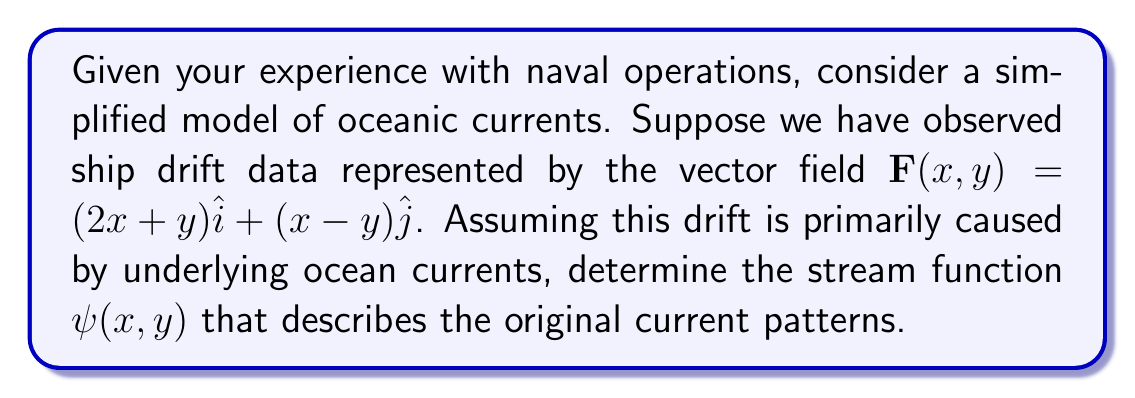Solve this math problem. To solve this inverse problem and determine the original oceanic current patterns from the observed ship drift data, we'll follow these steps:

1) Recall that for a two-dimensional incompressible flow, the velocity field $\mathbf{v}$ can be expressed in terms of a stream function $\psi$ as:

   $\mathbf{v} = \nabla \times (\psi \hat{k}) = \left(\frac{\partial \psi}{\partial y}\right)\hat{i} - \left(\frac{\partial \psi}{\partial x}\right)\hat{j}$

2) In our case, we're given the drift vector field $\mathbf{F}$, which we assume represents the velocity field of the ocean currents:

   $\mathbf{F}(x,y) = (2x+y)\hat{i} + (x-y)\hat{j}$

3) Comparing this with the expression for $\mathbf{v}$ in terms of $\psi$, we can write:

   $\frac{\partial \psi}{\partial y} = 2x+y$
   $-\frac{\partial \psi}{\partial x} = x-y$

4) To find $\psi$, we need to integrate these partial differential equations. Let's start with the first equation:

   $\psi(x,y) = \int (2x+y) dy = 2xy + \frac{1}{2}y^2 + f(x)$

   where $f(x)$ is an arbitrary function of $x$.

5) Now, we can use the second equation to determine $f(x)$:

   $-\frac{\partial \psi}{\partial x} = -\left(2y + f'(x)\right) = x-y$

6) Comparing terms:

   $f'(x) = -x$
   $2y = -y$

   The second equation is satisfied, and we can integrate the first to get:

   $f(x) = -\frac{1}{2}x^2 + C$

   where $C$ is an arbitrary constant.

7) Therefore, the stream function is:

   $\psi(x,y) = 2xy + \frac{1}{2}y^2 - \frac{1}{2}x^2 + C$

   The constant $C$ doesn't affect the flow pattern, so we can set it to zero for simplicity.
Answer: $\psi(x,y) = 2xy + \frac{1}{2}y^2 - \frac{1}{2}x^2$ 